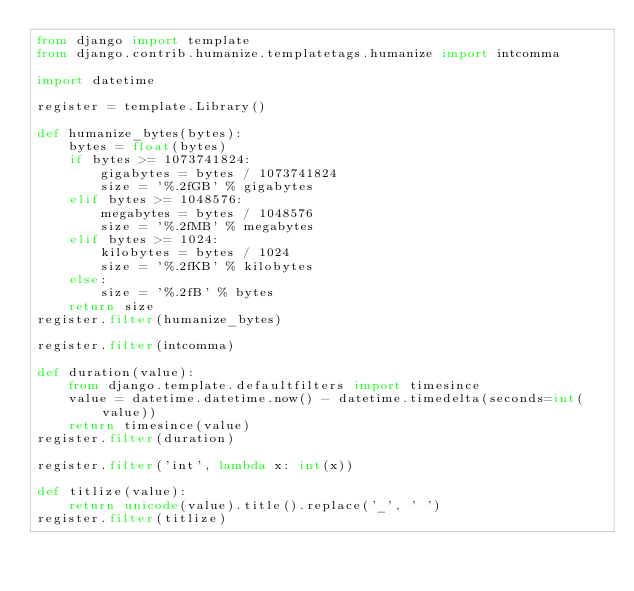Convert code to text. <code><loc_0><loc_0><loc_500><loc_500><_Python_>from django import template
from django.contrib.humanize.templatetags.humanize import intcomma

import datetime

register = template.Library()

def humanize_bytes(bytes):
    bytes = float(bytes)
    if bytes >= 1073741824:
        gigabytes = bytes / 1073741824
        size = '%.2fGB' % gigabytes
    elif bytes >= 1048576:
        megabytes = bytes / 1048576
        size = '%.2fMB' % megabytes
    elif bytes >= 1024:
        kilobytes = bytes / 1024
        size = '%.2fKB' % kilobytes
    else:
        size = '%.2fB' % bytes
    return size
register.filter(humanize_bytes)

register.filter(intcomma)

def duration(value):
    from django.template.defaultfilters import timesince
    value = datetime.datetime.now() - datetime.timedelta(seconds=int(value))
    return timesince(value)
register.filter(duration)

register.filter('int', lambda x: int(x))

def titlize(value):
    return unicode(value).title().replace('_', ' ')
register.filter(titlize)</code> 